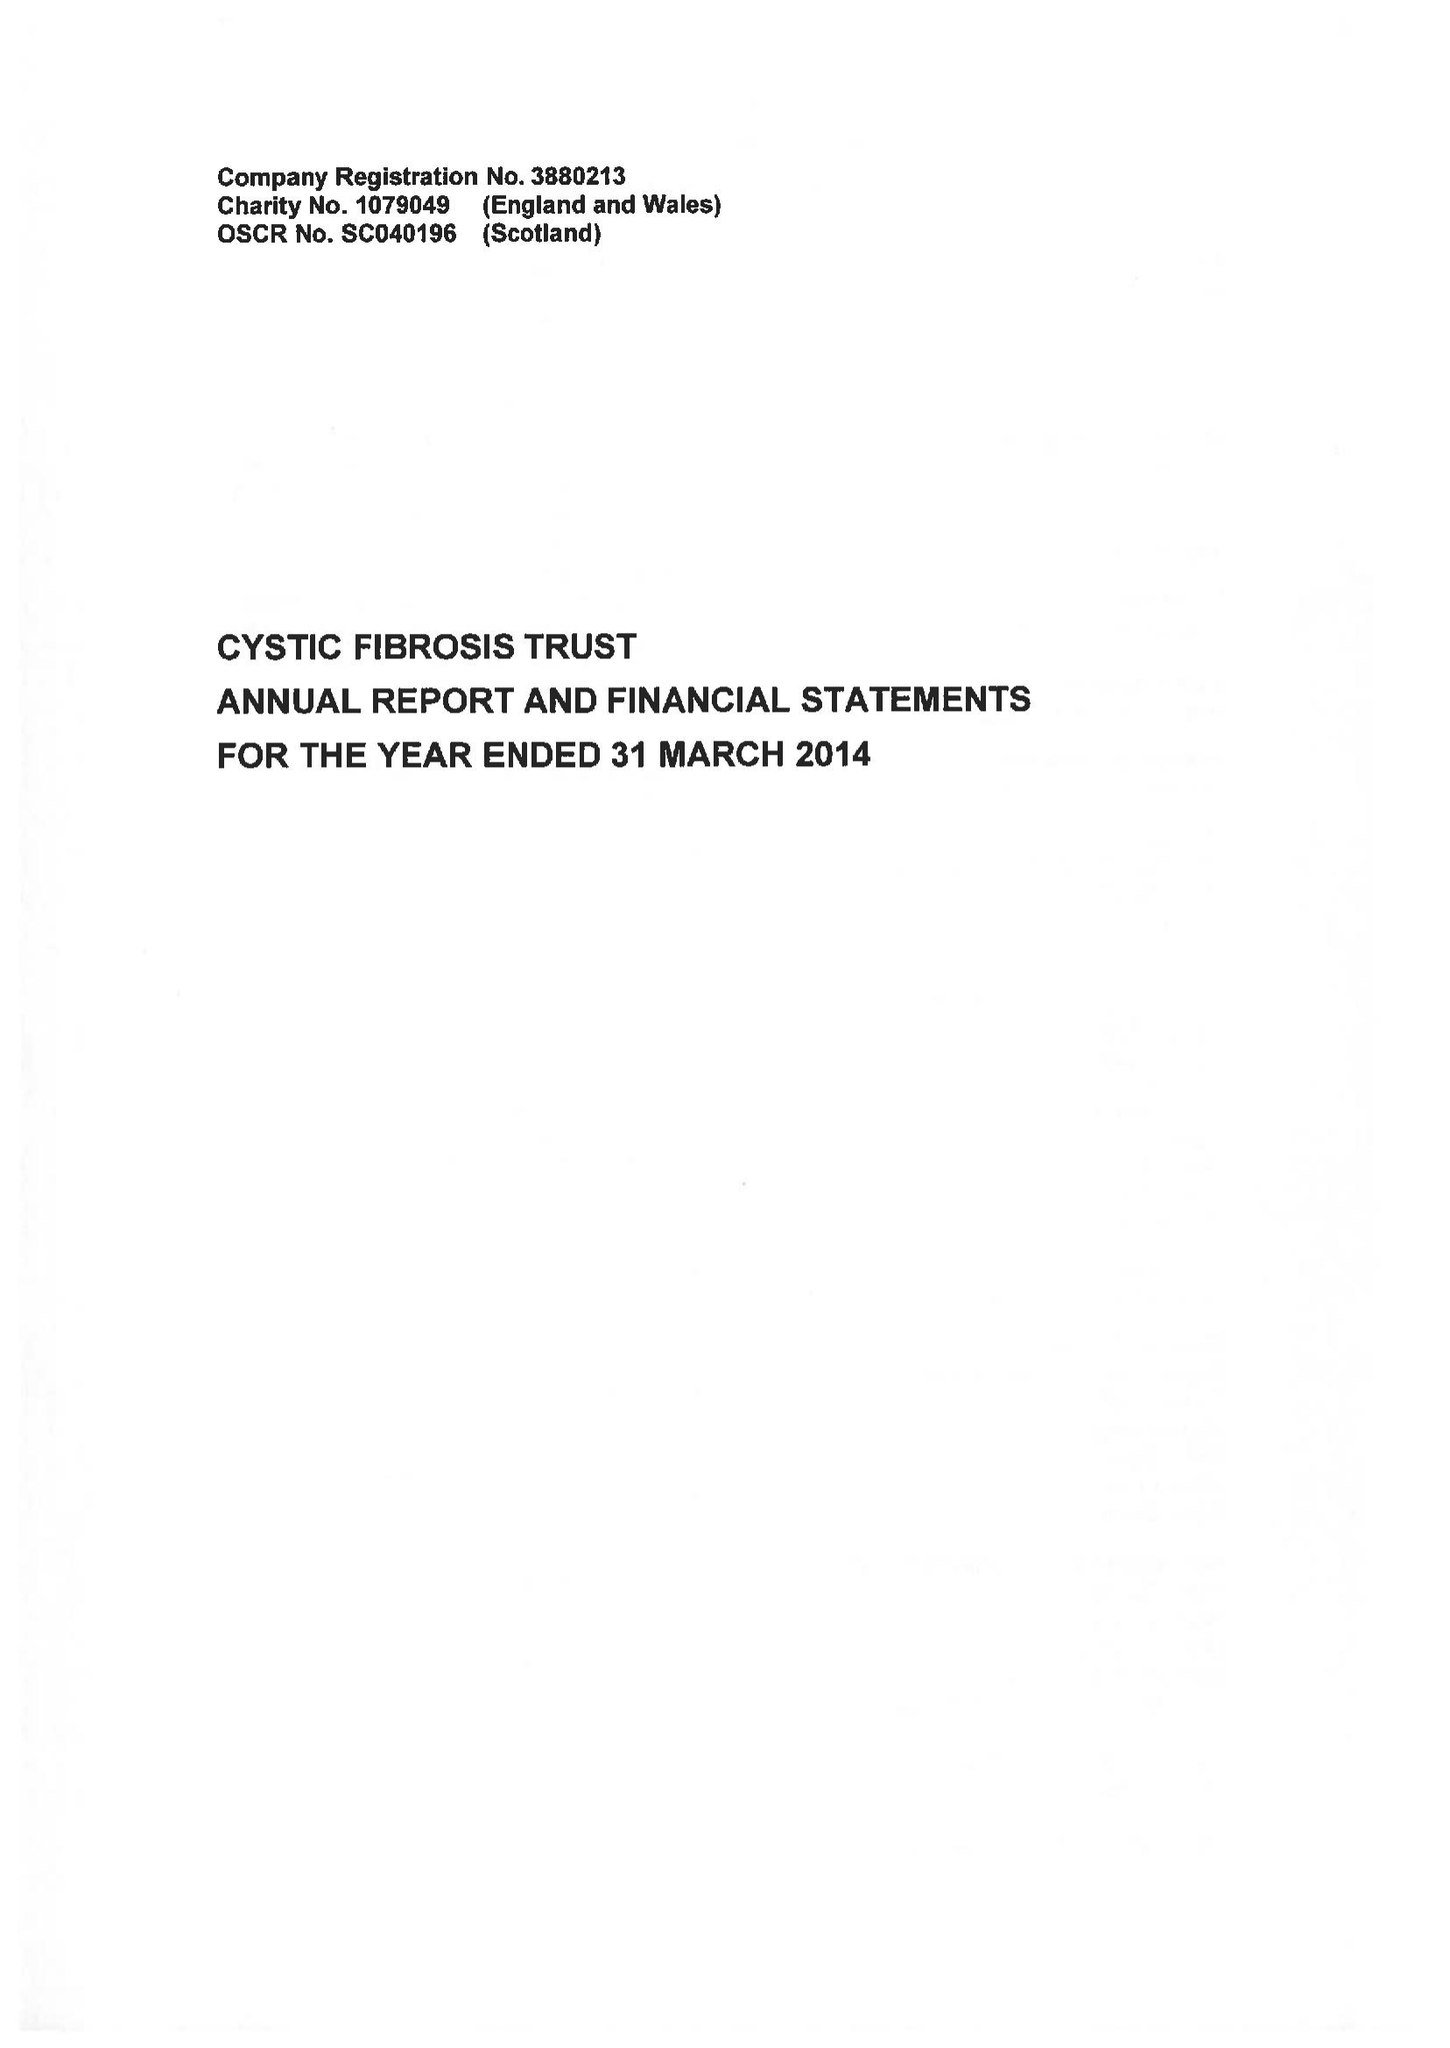What is the value for the charity_name?
Answer the question using a single word or phrase. Cystic Fibrosis Trust 